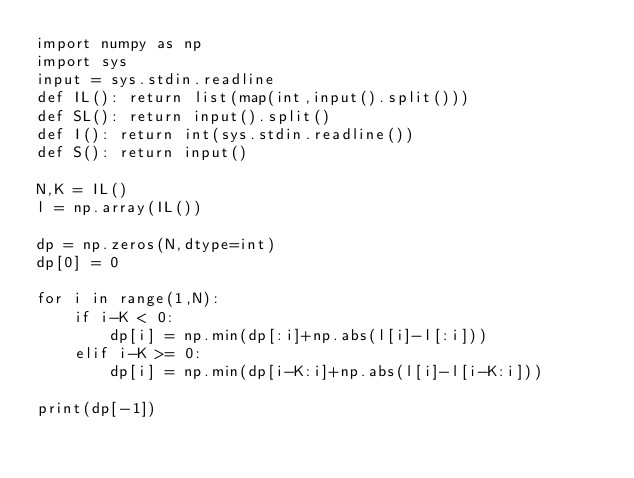<code> <loc_0><loc_0><loc_500><loc_500><_Python_>import numpy as np
import sys
input = sys.stdin.readline
def IL(): return list(map(int,input().split()))
def SL(): return input().split()
def I(): return int(sys.stdin.readline())
def S(): return input()

N,K = IL()
l = np.array(IL())

dp = np.zeros(N,dtype=int)
dp[0] = 0

for i in range(1,N):
    if i-K < 0:
        dp[i] = np.min(dp[:i]+np.abs(l[i]-l[:i]))
    elif i-K >= 0:
        dp[i] = np.min(dp[i-K:i]+np.abs(l[i]-l[i-K:i]))

print(dp[-1])</code> 